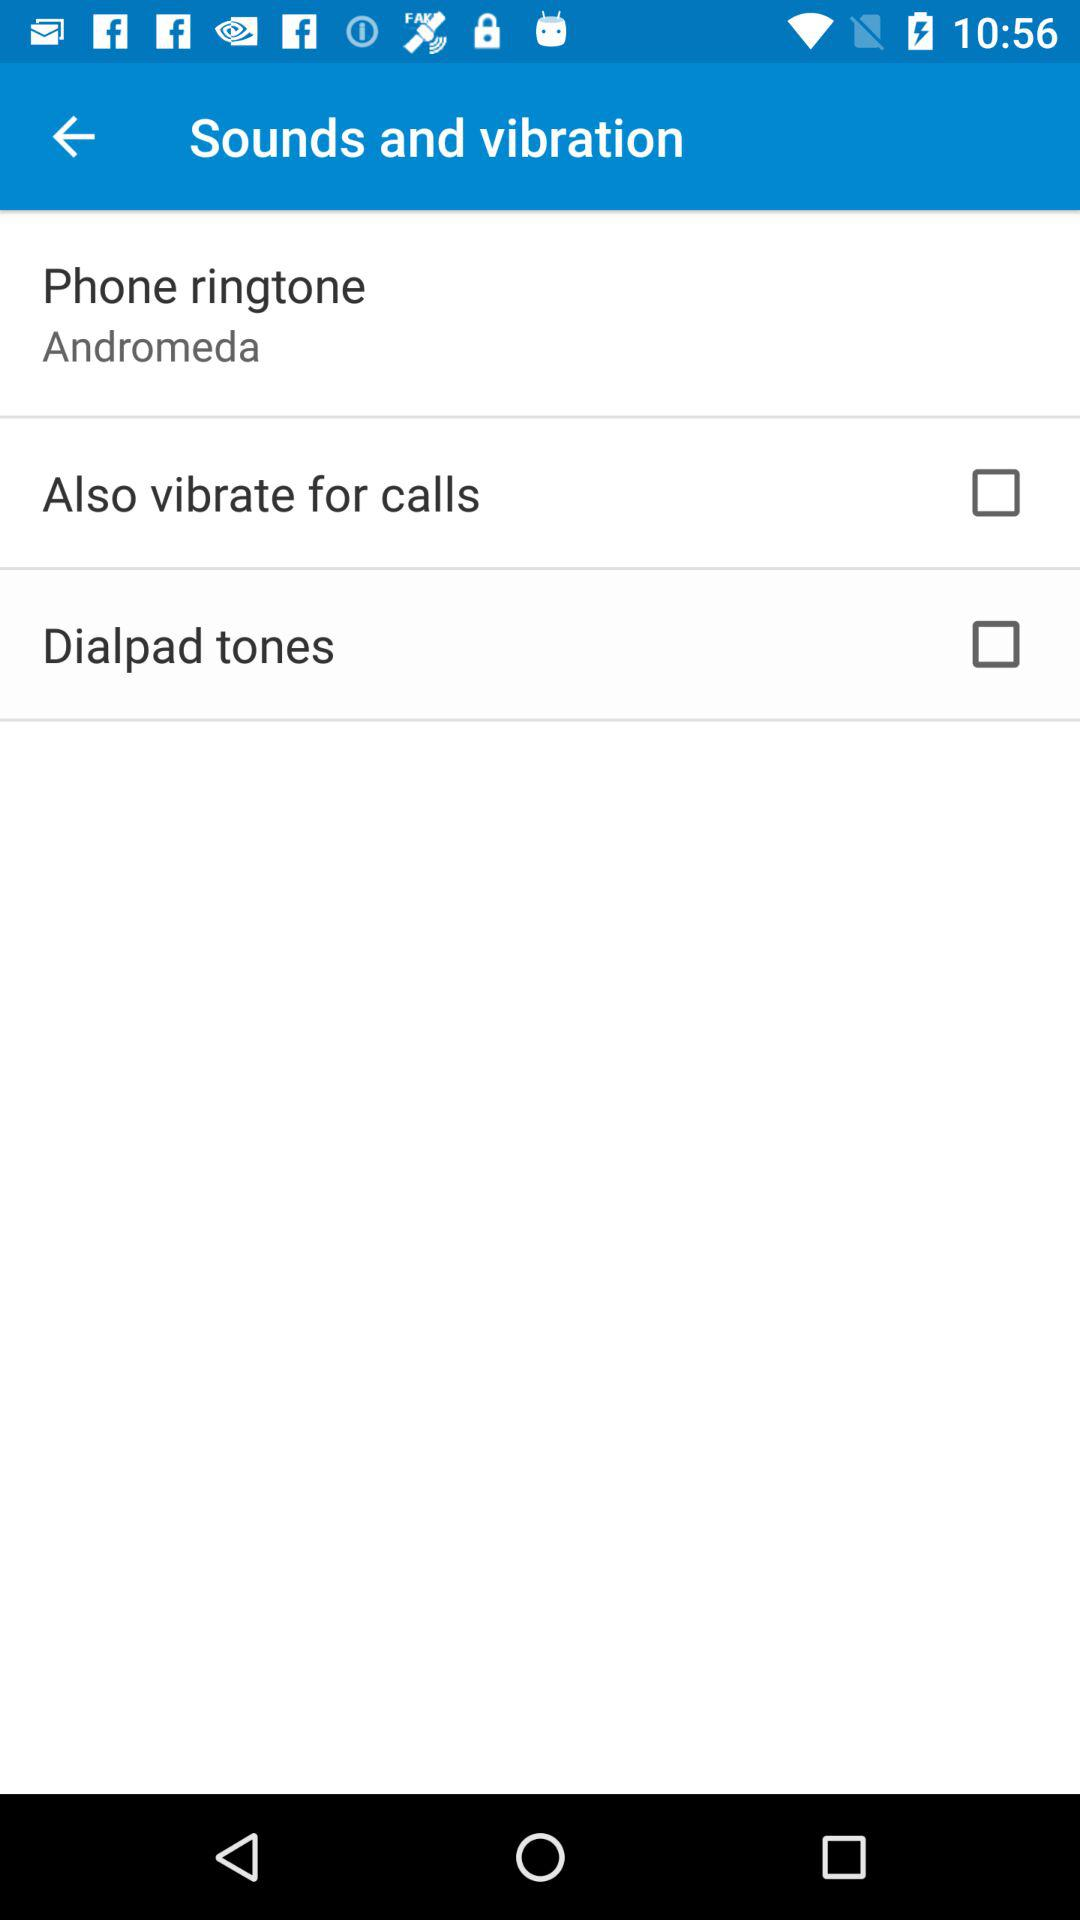What is the status of dialpad tones? The status is "off". 